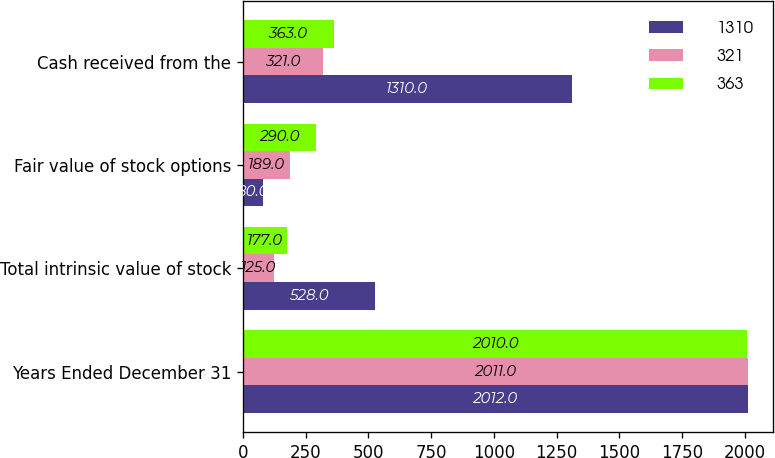Convert chart. <chart><loc_0><loc_0><loc_500><loc_500><stacked_bar_chart><ecel><fcel>Years Ended December 31<fcel>Total intrinsic value of stock<fcel>Fair value of stock options<fcel>Cash received from the<nl><fcel>1310<fcel>2012<fcel>528<fcel>80<fcel>1310<nl><fcel>321<fcel>2011<fcel>125<fcel>189<fcel>321<nl><fcel>363<fcel>2010<fcel>177<fcel>290<fcel>363<nl></chart> 